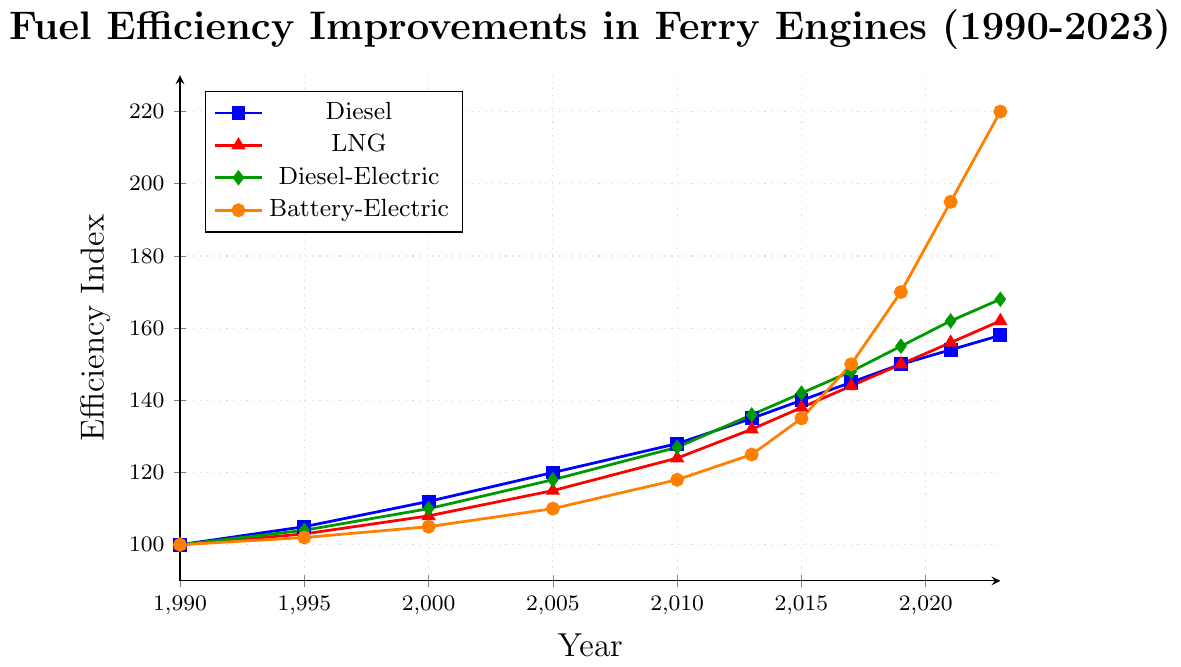What propulsion type shows the greatest improvement in efficiency from 1990 to 2023? Analyze the data points for each propulsion type in 1990 and 2023. Diesel improved from 100 to 158, LNG from 100 to 162, Diesel-Electric from 100 to 168, and Battery-Electric from 100 to 220. The greatest improvement is seen in Battery-Electric.
Answer: Battery-Electric By how many points did Diesel-Electric improve from 2010 to 2023? Refer to the data points for Diesel-Electric in 2010 and 2023. In 2010, the efficiency was 127, and in 2023, it is 168. The difference is 168 - 127.
Answer: 41 Which year see the largest efficiency improvement for Battery-Electric propulsion? Compare the differences between consecutive years for Battery-Electric efficiency. The largest jump is between 2019 (170) and 2021 (195).
Answer: 2019-2021 What is the efficiency index of LNG propulsion in 2013? Simply refer to the data point for LNG in 2013, which is marked on the plot.
Answer: 132 Compare the efficiency trend of Diesel and LNG from 2000 to 2005. Which one improved more and by how much? For Diesel, from 2000 (112) to 2005 (120), the improvement is 120 - 112 = 8. For LNG, from 2000 (108) to 2005 (115), the improvement is 115 - 108 = 7. Therefore, Diesel improved by 1 point more than LNG.
Answer: Diesel, by 1 point How does the efficiency of Battery-Electric propulsion in 2023 compare to that of Diesel in the same year? Refer to the efficiency indices of Battery-Electric (220) and Diesel (158) in 2023. 220 is significantly higher than 158.
Answer: Battery-Electric is higher Calculate the average efficiency of Diesel propulsion from 1990 to 2023. Sum the Diesel efficiency values from each year: 100 + 105 + 112 + 120 + 128 + 135 + 140 + 145 + 150 + 154 + 158 = 1447. Divide by the number of data points (11): 1447 / 11.
Answer: 131.55 Which propulsion type consistently shows the highest initial efficiency index values over all given years? Compare initial values in 1990, then trace each year's progression for each propulsion type. All started equal at 100, so the trend from the beginning to end determines the question. Battery-Electric shows the highest indices consistently from 2017 onwards.
Answer: Battery-Electric Which propulsion type exhibited the slowest rate of efficiency improvement from 2015 to 2023? Calculate the differences for each propulsion type from 2015 to 2023: Diesel (158-140=18), LNG (162-138=24), Diesel-Electric (168-142=26), Battery-Electric (220-135=85). Diesel has the slowest improvement rate of 18 points.
Answer: Diesel 